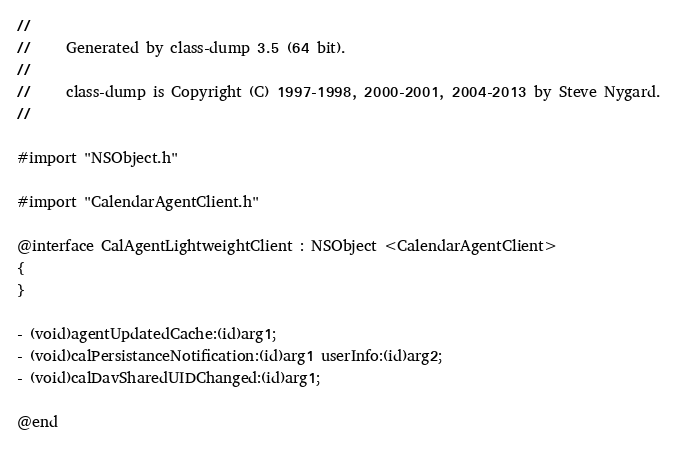<code> <loc_0><loc_0><loc_500><loc_500><_C_>//
//     Generated by class-dump 3.5 (64 bit).
//
//     class-dump is Copyright (C) 1997-1998, 2000-2001, 2004-2013 by Steve Nygard.
//

#import "NSObject.h"

#import "CalendarAgentClient.h"

@interface CalAgentLightweightClient : NSObject <CalendarAgentClient>
{
}

- (void)agentUpdatedCache:(id)arg1;
- (void)calPersistanceNotification:(id)arg1 userInfo:(id)arg2;
- (void)calDavSharedUIDChanged:(id)arg1;

@end

</code> 